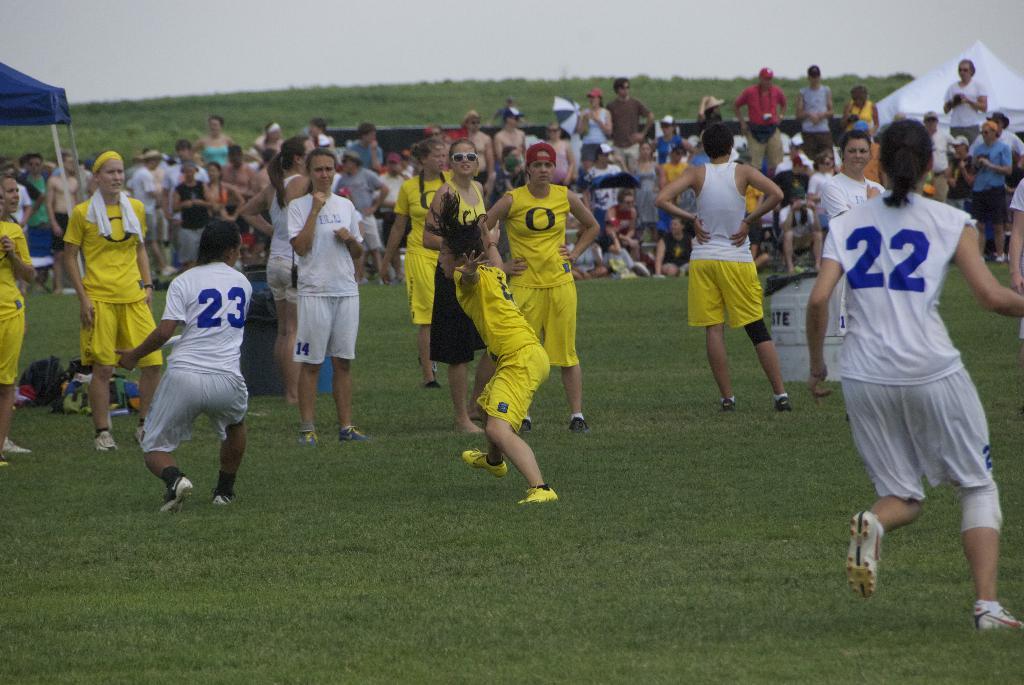What is the two numbers of the white team?
Provide a short and direct response. 23 22. What is on the yellow shirt of the person in the middle?
Your answer should be very brief. O. 